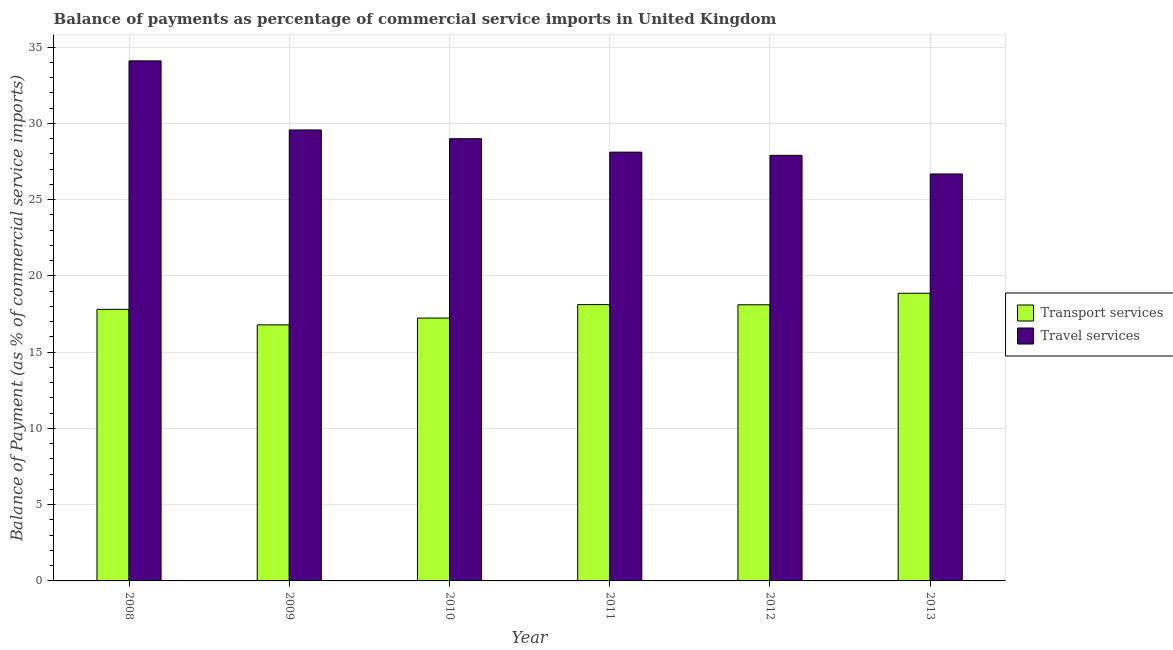How many different coloured bars are there?
Provide a succinct answer. 2. How many bars are there on the 4th tick from the right?
Provide a succinct answer. 2. What is the balance of payments of transport services in 2009?
Give a very brief answer. 16.79. Across all years, what is the maximum balance of payments of transport services?
Your answer should be very brief. 18.86. Across all years, what is the minimum balance of payments of transport services?
Make the answer very short. 16.79. What is the total balance of payments of transport services in the graph?
Offer a very short reply. 106.9. What is the difference between the balance of payments of travel services in 2008 and that in 2009?
Give a very brief answer. 4.53. What is the difference between the balance of payments of transport services in 2013 and the balance of payments of travel services in 2011?
Offer a terse response. 0.75. What is the average balance of payments of travel services per year?
Keep it short and to the point. 29.22. In the year 2009, what is the difference between the balance of payments of transport services and balance of payments of travel services?
Your response must be concise. 0. What is the ratio of the balance of payments of travel services in 2010 to that in 2011?
Provide a short and direct response. 1.03. What is the difference between the highest and the second highest balance of payments of transport services?
Offer a very short reply. 0.75. What is the difference between the highest and the lowest balance of payments of travel services?
Your response must be concise. 7.41. Is the sum of the balance of payments of transport services in 2010 and 2013 greater than the maximum balance of payments of travel services across all years?
Your answer should be compact. Yes. What does the 2nd bar from the left in 2009 represents?
Your answer should be very brief. Travel services. What does the 2nd bar from the right in 2008 represents?
Provide a short and direct response. Transport services. How many years are there in the graph?
Provide a succinct answer. 6. What is the difference between two consecutive major ticks on the Y-axis?
Your answer should be very brief. 5. Does the graph contain any zero values?
Your answer should be compact. No. Does the graph contain grids?
Offer a very short reply. Yes. Where does the legend appear in the graph?
Ensure brevity in your answer.  Center right. How many legend labels are there?
Offer a very short reply. 2. How are the legend labels stacked?
Keep it short and to the point. Vertical. What is the title of the graph?
Provide a succinct answer. Balance of payments as percentage of commercial service imports in United Kingdom. What is the label or title of the X-axis?
Provide a succinct answer. Year. What is the label or title of the Y-axis?
Ensure brevity in your answer.  Balance of Payment (as % of commercial service imports). What is the Balance of Payment (as % of commercial service imports) in Transport services in 2008?
Offer a terse response. 17.8. What is the Balance of Payment (as % of commercial service imports) in Travel services in 2008?
Your response must be concise. 34.09. What is the Balance of Payment (as % of commercial service imports) of Transport services in 2009?
Offer a very short reply. 16.79. What is the Balance of Payment (as % of commercial service imports) in Travel services in 2009?
Offer a terse response. 29.56. What is the Balance of Payment (as % of commercial service imports) in Transport services in 2010?
Make the answer very short. 17.23. What is the Balance of Payment (as % of commercial service imports) in Travel services in 2010?
Provide a short and direct response. 28.99. What is the Balance of Payment (as % of commercial service imports) in Transport services in 2011?
Make the answer very short. 18.11. What is the Balance of Payment (as % of commercial service imports) of Travel services in 2011?
Offer a very short reply. 28.11. What is the Balance of Payment (as % of commercial service imports) in Transport services in 2012?
Keep it short and to the point. 18.1. What is the Balance of Payment (as % of commercial service imports) in Travel services in 2012?
Ensure brevity in your answer.  27.9. What is the Balance of Payment (as % of commercial service imports) of Transport services in 2013?
Your response must be concise. 18.86. What is the Balance of Payment (as % of commercial service imports) of Travel services in 2013?
Ensure brevity in your answer.  26.68. Across all years, what is the maximum Balance of Payment (as % of commercial service imports) of Transport services?
Offer a very short reply. 18.86. Across all years, what is the maximum Balance of Payment (as % of commercial service imports) of Travel services?
Provide a succinct answer. 34.09. Across all years, what is the minimum Balance of Payment (as % of commercial service imports) of Transport services?
Provide a succinct answer. 16.79. Across all years, what is the minimum Balance of Payment (as % of commercial service imports) of Travel services?
Your answer should be compact. 26.68. What is the total Balance of Payment (as % of commercial service imports) of Transport services in the graph?
Provide a succinct answer. 106.9. What is the total Balance of Payment (as % of commercial service imports) of Travel services in the graph?
Your response must be concise. 175.33. What is the difference between the Balance of Payment (as % of commercial service imports) in Transport services in 2008 and that in 2009?
Your answer should be very brief. 1.02. What is the difference between the Balance of Payment (as % of commercial service imports) in Travel services in 2008 and that in 2009?
Keep it short and to the point. 4.53. What is the difference between the Balance of Payment (as % of commercial service imports) in Transport services in 2008 and that in 2010?
Provide a short and direct response. 0.57. What is the difference between the Balance of Payment (as % of commercial service imports) of Travel services in 2008 and that in 2010?
Give a very brief answer. 5.1. What is the difference between the Balance of Payment (as % of commercial service imports) of Transport services in 2008 and that in 2011?
Offer a very short reply. -0.31. What is the difference between the Balance of Payment (as % of commercial service imports) of Travel services in 2008 and that in 2011?
Make the answer very short. 5.98. What is the difference between the Balance of Payment (as % of commercial service imports) in Transport services in 2008 and that in 2012?
Offer a very short reply. -0.3. What is the difference between the Balance of Payment (as % of commercial service imports) of Travel services in 2008 and that in 2012?
Give a very brief answer. 6.19. What is the difference between the Balance of Payment (as % of commercial service imports) of Transport services in 2008 and that in 2013?
Offer a very short reply. -1.05. What is the difference between the Balance of Payment (as % of commercial service imports) of Travel services in 2008 and that in 2013?
Provide a short and direct response. 7.41. What is the difference between the Balance of Payment (as % of commercial service imports) of Transport services in 2009 and that in 2010?
Ensure brevity in your answer.  -0.45. What is the difference between the Balance of Payment (as % of commercial service imports) in Travel services in 2009 and that in 2010?
Provide a short and direct response. 0.57. What is the difference between the Balance of Payment (as % of commercial service imports) of Transport services in 2009 and that in 2011?
Your response must be concise. -1.33. What is the difference between the Balance of Payment (as % of commercial service imports) in Travel services in 2009 and that in 2011?
Offer a very short reply. 1.46. What is the difference between the Balance of Payment (as % of commercial service imports) of Transport services in 2009 and that in 2012?
Provide a succinct answer. -1.32. What is the difference between the Balance of Payment (as % of commercial service imports) of Travel services in 2009 and that in 2012?
Make the answer very short. 1.66. What is the difference between the Balance of Payment (as % of commercial service imports) in Transport services in 2009 and that in 2013?
Make the answer very short. -2.07. What is the difference between the Balance of Payment (as % of commercial service imports) in Travel services in 2009 and that in 2013?
Offer a terse response. 2.88. What is the difference between the Balance of Payment (as % of commercial service imports) of Transport services in 2010 and that in 2011?
Make the answer very short. -0.88. What is the difference between the Balance of Payment (as % of commercial service imports) of Travel services in 2010 and that in 2011?
Offer a terse response. 0.88. What is the difference between the Balance of Payment (as % of commercial service imports) in Transport services in 2010 and that in 2012?
Make the answer very short. -0.87. What is the difference between the Balance of Payment (as % of commercial service imports) in Travel services in 2010 and that in 2012?
Make the answer very short. 1.09. What is the difference between the Balance of Payment (as % of commercial service imports) in Transport services in 2010 and that in 2013?
Offer a very short reply. -1.63. What is the difference between the Balance of Payment (as % of commercial service imports) of Travel services in 2010 and that in 2013?
Your response must be concise. 2.31. What is the difference between the Balance of Payment (as % of commercial service imports) in Transport services in 2011 and that in 2012?
Keep it short and to the point. 0.01. What is the difference between the Balance of Payment (as % of commercial service imports) of Travel services in 2011 and that in 2012?
Provide a short and direct response. 0.21. What is the difference between the Balance of Payment (as % of commercial service imports) in Transport services in 2011 and that in 2013?
Make the answer very short. -0.75. What is the difference between the Balance of Payment (as % of commercial service imports) in Travel services in 2011 and that in 2013?
Ensure brevity in your answer.  1.43. What is the difference between the Balance of Payment (as % of commercial service imports) in Transport services in 2012 and that in 2013?
Your answer should be compact. -0.76. What is the difference between the Balance of Payment (as % of commercial service imports) in Travel services in 2012 and that in 2013?
Your answer should be very brief. 1.22. What is the difference between the Balance of Payment (as % of commercial service imports) in Transport services in 2008 and the Balance of Payment (as % of commercial service imports) in Travel services in 2009?
Make the answer very short. -11.76. What is the difference between the Balance of Payment (as % of commercial service imports) of Transport services in 2008 and the Balance of Payment (as % of commercial service imports) of Travel services in 2010?
Offer a terse response. -11.19. What is the difference between the Balance of Payment (as % of commercial service imports) of Transport services in 2008 and the Balance of Payment (as % of commercial service imports) of Travel services in 2011?
Provide a succinct answer. -10.3. What is the difference between the Balance of Payment (as % of commercial service imports) in Transport services in 2008 and the Balance of Payment (as % of commercial service imports) in Travel services in 2012?
Ensure brevity in your answer.  -10.1. What is the difference between the Balance of Payment (as % of commercial service imports) of Transport services in 2008 and the Balance of Payment (as % of commercial service imports) of Travel services in 2013?
Provide a succinct answer. -8.88. What is the difference between the Balance of Payment (as % of commercial service imports) of Transport services in 2009 and the Balance of Payment (as % of commercial service imports) of Travel services in 2010?
Ensure brevity in your answer.  -12.2. What is the difference between the Balance of Payment (as % of commercial service imports) in Transport services in 2009 and the Balance of Payment (as % of commercial service imports) in Travel services in 2011?
Offer a very short reply. -11.32. What is the difference between the Balance of Payment (as % of commercial service imports) of Transport services in 2009 and the Balance of Payment (as % of commercial service imports) of Travel services in 2012?
Keep it short and to the point. -11.11. What is the difference between the Balance of Payment (as % of commercial service imports) of Transport services in 2009 and the Balance of Payment (as % of commercial service imports) of Travel services in 2013?
Offer a very short reply. -9.89. What is the difference between the Balance of Payment (as % of commercial service imports) in Transport services in 2010 and the Balance of Payment (as % of commercial service imports) in Travel services in 2011?
Provide a succinct answer. -10.88. What is the difference between the Balance of Payment (as % of commercial service imports) of Transport services in 2010 and the Balance of Payment (as % of commercial service imports) of Travel services in 2012?
Offer a very short reply. -10.67. What is the difference between the Balance of Payment (as % of commercial service imports) of Transport services in 2010 and the Balance of Payment (as % of commercial service imports) of Travel services in 2013?
Provide a succinct answer. -9.45. What is the difference between the Balance of Payment (as % of commercial service imports) in Transport services in 2011 and the Balance of Payment (as % of commercial service imports) in Travel services in 2012?
Make the answer very short. -9.79. What is the difference between the Balance of Payment (as % of commercial service imports) of Transport services in 2011 and the Balance of Payment (as % of commercial service imports) of Travel services in 2013?
Your response must be concise. -8.57. What is the difference between the Balance of Payment (as % of commercial service imports) in Transport services in 2012 and the Balance of Payment (as % of commercial service imports) in Travel services in 2013?
Offer a terse response. -8.58. What is the average Balance of Payment (as % of commercial service imports) of Transport services per year?
Ensure brevity in your answer.  17.82. What is the average Balance of Payment (as % of commercial service imports) in Travel services per year?
Your response must be concise. 29.22. In the year 2008, what is the difference between the Balance of Payment (as % of commercial service imports) in Transport services and Balance of Payment (as % of commercial service imports) in Travel services?
Provide a succinct answer. -16.29. In the year 2009, what is the difference between the Balance of Payment (as % of commercial service imports) in Transport services and Balance of Payment (as % of commercial service imports) in Travel services?
Your response must be concise. -12.78. In the year 2010, what is the difference between the Balance of Payment (as % of commercial service imports) of Transport services and Balance of Payment (as % of commercial service imports) of Travel services?
Your answer should be very brief. -11.76. In the year 2011, what is the difference between the Balance of Payment (as % of commercial service imports) of Transport services and Balance of Payment (as % of commercial service imports) of Travel services?
Offer a terse response. -10. In the year 2012, what is the difference between the Balance of Payment (as % of commercial service imports) in Transport services and Balance of Payment (as % of commercial service imports) in Travel services?
Offer a terse response. -9.8. In the year 2013, what is the difference between the Balance of Payment (as % of commercial service imports) of Transport services and Balance of Payment (as % of commercial service imports) of Travel services?
Offer a terse response. -7.82. What is the ratio of the Balance of Payment (as % of commercial service imports) in Transport services in 2008 to that in 2009?
Keep it short and to the point. 1.06. What is the ratio of the Balance of Payment (as % of commercial service imports) of Travel services in 2008 to that in 2009?
Offer a terse response. 1.15. What is the ratio of the Balance of Payment (as % of commercial service imports) of Transport services in 2008 to that in 2010?
Keep it short and to the point. 1.03. What is the ratio of the Balance of Payment (as % of commercial service imports) of Travel services in 2008 to that in 2010?
Your response must be concise. 1.18. What is the ratio of the Balance of Payment (as % of commercial service imports) of Transport services in 2008 to that in 2011?
Your answer should be compact. 0.98. What is the ratio of the Balance of Payment (as % of commercial service imports) in Travel services in 2008 to that in 2011?
Give a very brief answer. 1.21. What is the ratio of the Balance of Payment (as % of commercial service imports) of Transport services in 2008 to that in 2012?
Make the answer very short. 0.98. What is the ratio of the Balance of Payment (as % of commercial service imports) in Travel services in 2008 to that in 2012?
Keep it short and to the point. 1.22. What is the ratio of the Balance of Payment (as % of commercial service imports) of Transport services in 2008 to that in 2013?
Your answer should be compact. 0.94. What is the ratio of the Balance of Payment (as % of commercial service imports) of Travel services in 2008 to that in 2013?
Your answer should be very brief. 1.28. What is the ratio of the Balance of Payment (as % of commercial service imports) of Transport services in 2009 to that in 2010?
Offer a very short reply. 0.97. What is the ratio of the Balance of Payment (as % of commercial service imports) in Travel services in 2009 to that in 2010?
Give a very brief answer. 1.02. What is the ratio of the Balance of Payment (as % of commercial service imports) in Transport services in 2009 to that in 2011?
Keep it short and to the point. 0.93. What is the ratio of the Balance of Payment (as % of commercial service imports) in Travel services in 2009 to that in 2011?
Ensure brevity in your answer.  1.05. What is the ratio of the Balance of Payment (as % of commercial service imports) of Transport services in 2009 to that in 2012?
Your response must be concise. 0.93. What is the ratio of the Balance of Payment (as % of commercial service imports) in Travel services in 2009 to that in 2012?
Provide a short and direct response. 1.06. What is the ratio of the Balance of Payment (as % of commercial service imports) of Transport services in 2009 to that in 2013?
Your answer should be very brief. 0.89. What is the ratio of the Balance of Payment (as % of commercial service imports) in Travel services in 2009 to that in 2013?
Provide a succinct answer. 1.11. What is the ratio of the Balance of Payment (as % of commercial service imports) of Transport services in 2010 to that in 2011?
Your answer should be compact. 0.95. What is the ratio of the Balance of Payment (as % of commercial service imports) of Travel services in 2010 to that in 2011?
Keep it short and to the point. 1.03. What is the ratio of the Balance of Payment (as % of commercial service imports) in Transport services in 2010 to that in 2012?
Give a very brief answer. 0.95. What is the ratio of the Balance of Payment (as % of commercial service imports) in Travel services in 2010 to that in 2012?
Keep it short and to the point. 1.04. What is the ratio of the Balance of Payment (as % of commercial service imports) in Transport services in 2010 to that in 2013?
Offer a terse response. 0.91. What is the ratio of the Balance of Payment (as % of commercial service imports) of Travel services in 2010 to that in 2013?
Your answer should be very brief. 1.09. What is the ratio of the Balance of Payment (as % of commercial service imports) in Transport services in 2011 to that in 2012?
Give a very brief answer. 1. What is the ratio of the Balance of Payment (as % of commercial service imports) in Travel services in 2011 to that in 2012?
Offer a terse response. 1.01. What is the ratio of the Balance of Payment (as % of commercial service imports) of Transport services in 2011 to that in 2013?
Make the answer very short. 0.96. What is the ratio of the Balance of Payment (as % of commercial service imports) in Travel services in 2011 to that in 2013?
Your response must be concise. 1.05. What is the ratio of the Balance of Payment (as % of commercial service imports) in Travel services in 2012 to that in 2013?
Provide a succinct answer. 1.05. What is the difference between the highest and the second highest Balance of Payment (as % of commercial service imports) of Transport services?
Ensure brevity in your answer.  0.75. What is the difference between the highest and the second highest Balance of Payment (as % of commercial service imports) in Travel services?
Provide a succinct answer. 4.53. What is the difference between the highest and the lowest Balance of Payment (as % of commercial service imports) in Transport services?
Offer a terse response. 2.07. What is the difference between the highest and the lowest Balance of Payment (as % of commercial service imports) in Travel services?
Your answer should be compact. 7.41. 